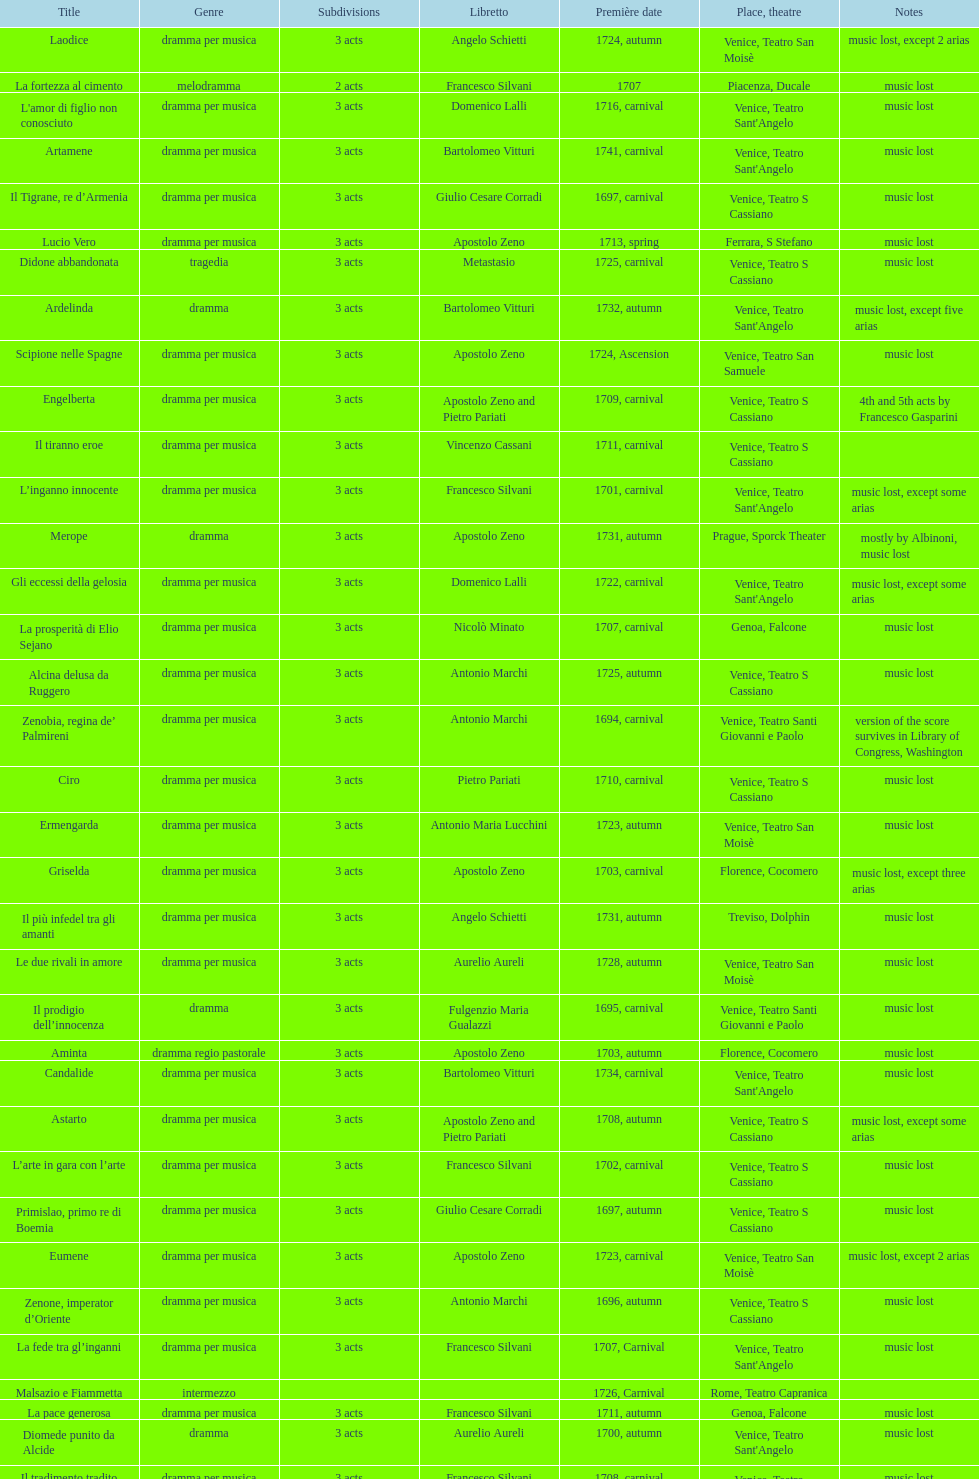What number of acts does il giustino have? 5. 